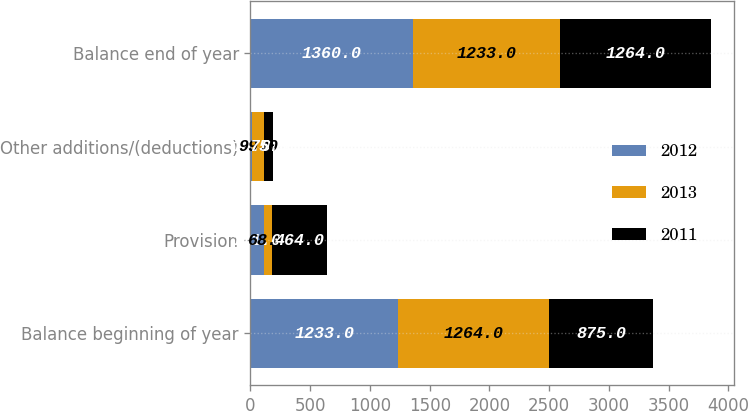Convert chart. <chart><loc_0><loc_0><loc_500><loc_500><stacked_bar_chart><ecel><fcel>Balance beginning of year<fcel>Provision<fcel>Other additions/(deductions)<fcel>Balance end of year<nl><fcel>2012<fcel>1233<fcel>111<fcel>16<fcel>1360<nl><fcel>2013<fcel>1264<fcel>68<fcel>99<fcel>1233<nl><fcel>2011<fcel>875<fcel>464<fcel>75<fcel>1264<nl></chart> 